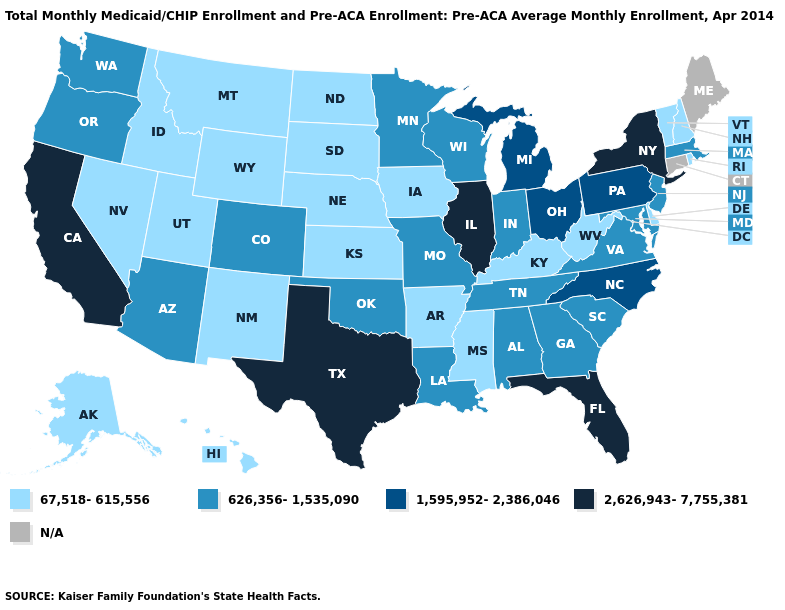Does the map have missing data?
Keep it brief. Yes. What is the value of New Hampshire?
Answer briefly. 67,518-615,556. Which states have the lowest value in the USA?
Answer briefly. Alaska, Arkansas, Delaware, Hawaii, Idaho, Iowa, Kansas, Kentucky, Mississippi, Montana, Nebraska, Nevada, New Hampshire, New Mexico, North Dakota, Rhode Island, South Dakota, Utah, Vermont, West Virginia, Wyoming. What is the value of Oklahoma?
Answer briefly. 626,356-1,535,090. Name the states that have a value in the range 67,518-615,556?
Write a very short answer. Alaska, Arkansas, Delaware, Hawaii, Idaho, Iowa, Kansas, Kentucky, Mississippi, Montana, Nebraska, Nevada, New Hampshire, New Mexico, North Dakota, Rhode Island, South Dakota, Utah, Vermont, West Virginia, Wyoming. Which states have the lowest value in the USA?
Short answer required. Alaska, Arkansas, Delaware, Hawaii, Idaho, Iowa, Kansas, Kentucky, Mississippi, Montana, Nebraska, Nevada, New Hampshire, New Mexico, North Dakota, Rhode Island, South Dakota, Utah, Vermont, West Virginia, Wyoming. Does the map have missing data?
Answer briefly. Yes. What is the value of California?
Keep it brief. 2,626,943-7,755,381. Among the states that border Indiana , does Kentucky have the highest value?
Be succinct. No. Which states hav the highest value in the West?
Answer briefly. California. What is the lowest value in the MidWest?
Concise answer only. 67,518-615,556. Name the states that have a value in the range 1,595,952-2,386,046?
Answer briefly. Michigan, North Carolina, Ohio, Pennsylvania. Which states have the lowest value in the USA?
Quick response, please. Alaska, Arkansas, Delaware, Hawaii, Idaho, Iowa, Kansas, Kentucky, Mississippi, Montana, Nebraska, Nevada, New Hampshire, New Mexico, North Dakota, Rhode Island, South Dakota, Utah, Vermont, West Virginia, Wyoming. Name the states that have a value in the range 1,595,952-2,386,046?
Be succinct. Michigan, North Carolina, Ohio, Pennsylvania. What is the lowest value in the USA?
Keep it brief. 67,518-615,556. 